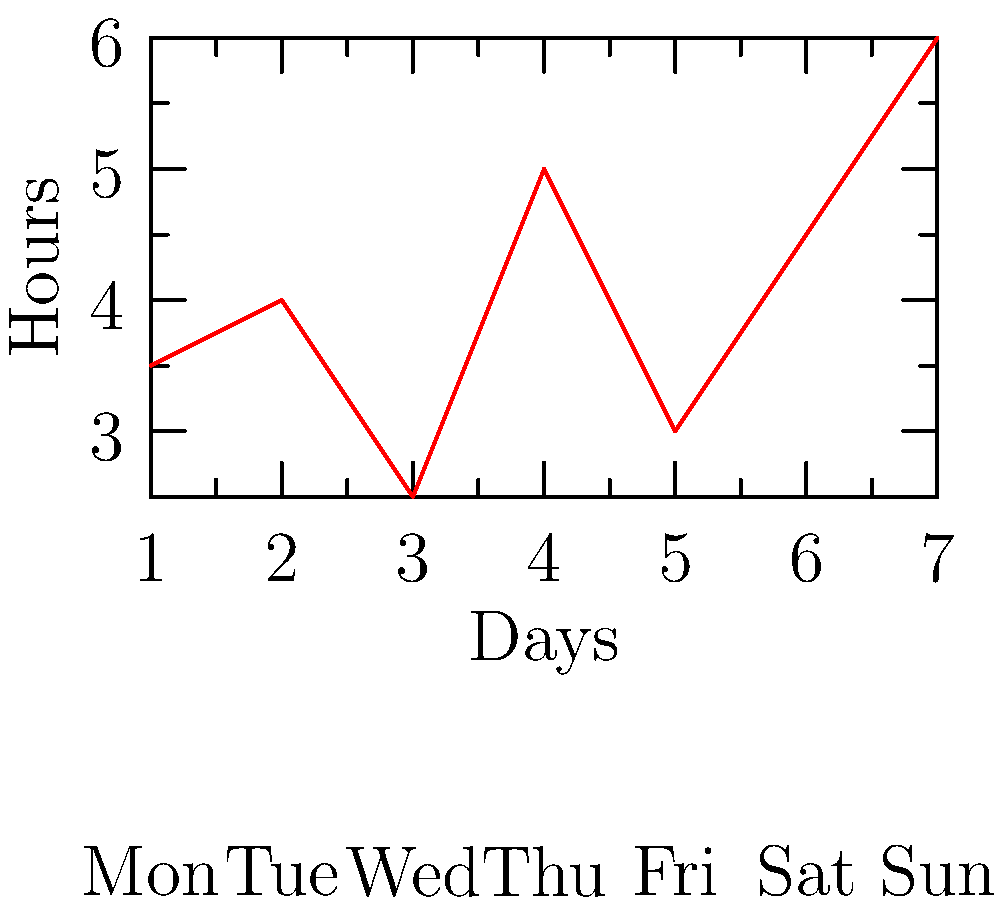The graph shows your teenager's daily social media usage over a week. On which day did their usage increase the most compared to the previous day? To find the day with the largest increase in social media usage compared to the previous day, we need to calculate the difference in hours between consecutive days:

1. Tuesday to Wednesday: $4 - 3.5 = 0.5$ hours increase
2. Wednesday to Thursday: $2.5 - 4 = -1.5$ hours (decrease)
3. Thursday to Friday: $5 - 2.5 = 2.5$ hours increase
4. Friday to Saturday: $3 - 5 = -2$ hours (decrease)
5. Saturday to Sunday: $4.5 - 3 = 1.5$ hours increase
6. Sunday to Monday: $6 - 4.5 = 1.5$ hours increase

The largest increase is 2.5 hours, which occurred from Thursday to Friday.
Answer: Friday 